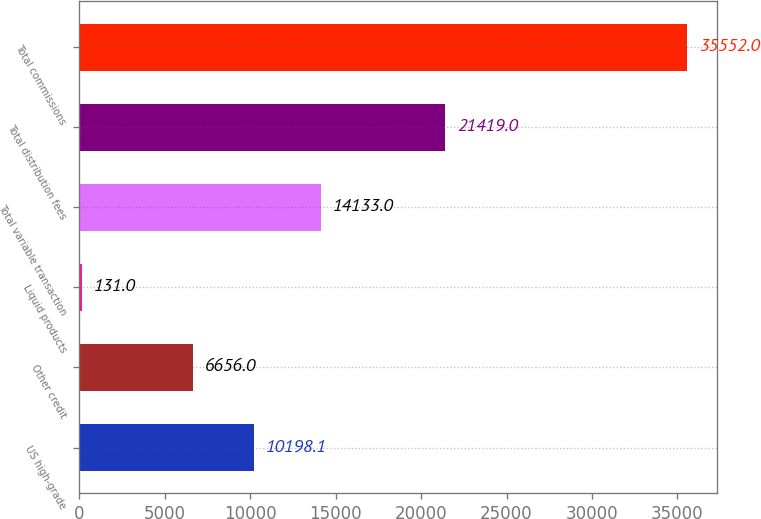Convert chart. <chart><loc_0><loc_0><loc_500><loc_500><bar_chart><fcel>US high-grade<fcel>Other credit<fcel>Liquid products<fcel>Total variable transaction<fcel>Total distribution fees<fcel>Total commissions<nl><fcel>10198.1<fcel>6656<fcel>131<fcel>14133<fcel>21419<fcel>35552<nl></chart> 